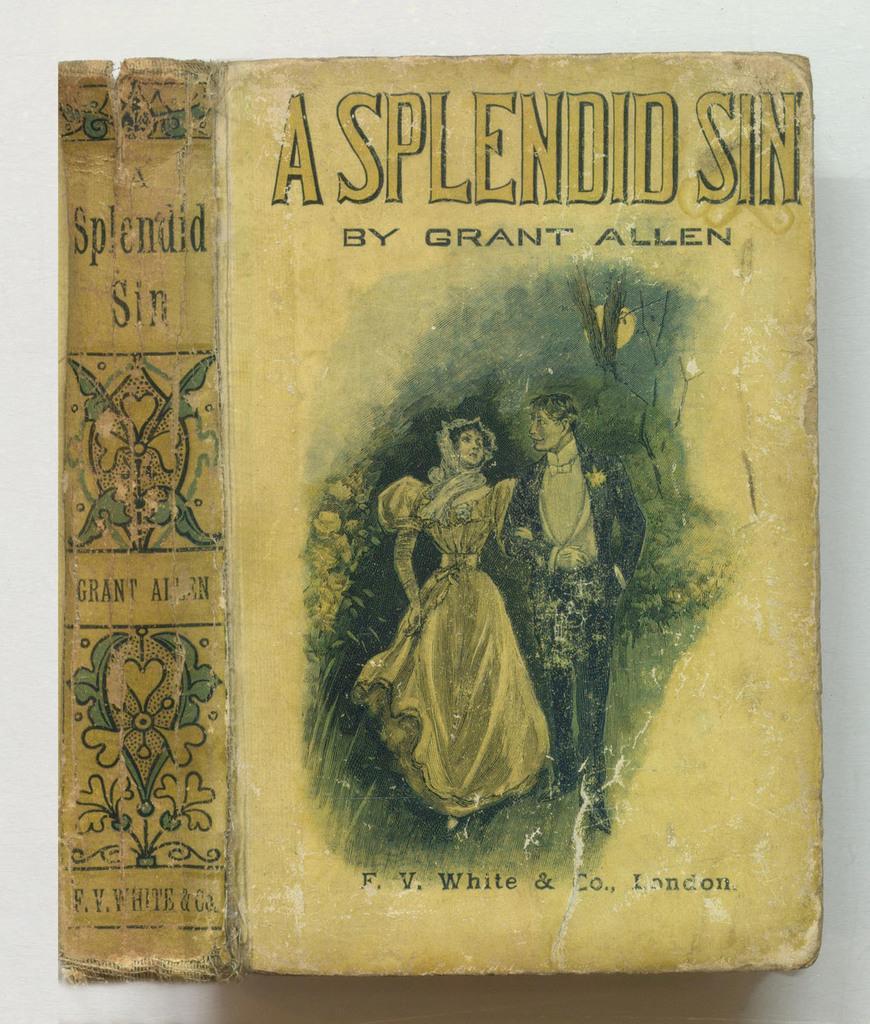<image>
Describe the image concisely. A cover of an old book called A Splendid Sin 